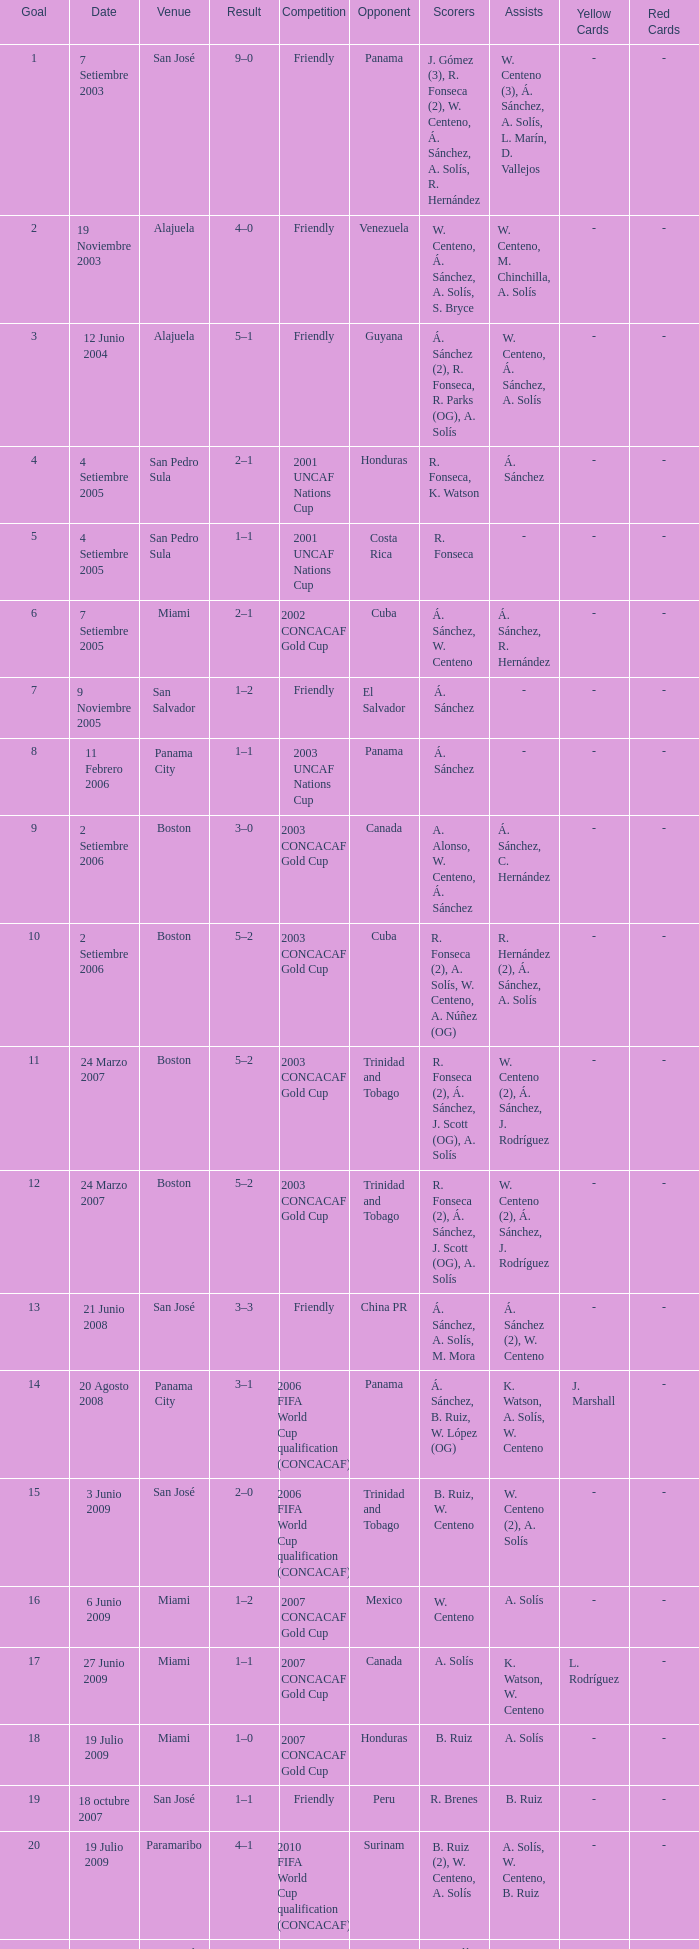How was the competition in which 6 goals were made? 2002 CONCACAF Gold Cup. 